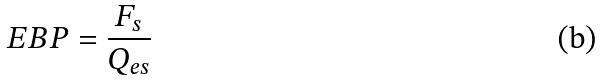Convert formula to latex. <formula><loc_0><loc_0><loc_500><loc_500>E B P = \frac { F _ { s } } { Q _ { e s } }</formula> 